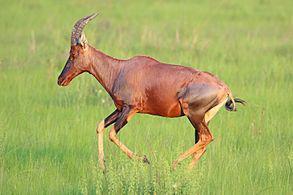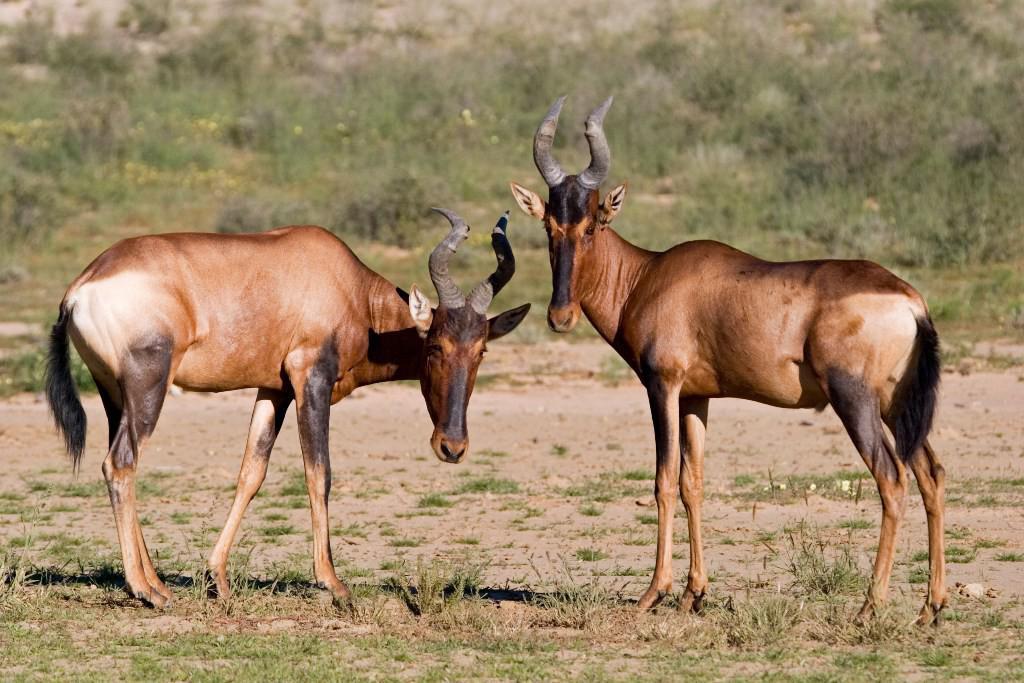The first image is the image on the left, the second image is the image on the right. Analyze the images presented: Is the assertion "The right image contains at least three hartebeest's." valid? Answer yes or no. No. The first image is the image on the left, the second image is the image on the right. Analyze the images presented: Is the assertion "All hooved animals in one image have both front legs off the ground." valid? Answer yes or no. No. 